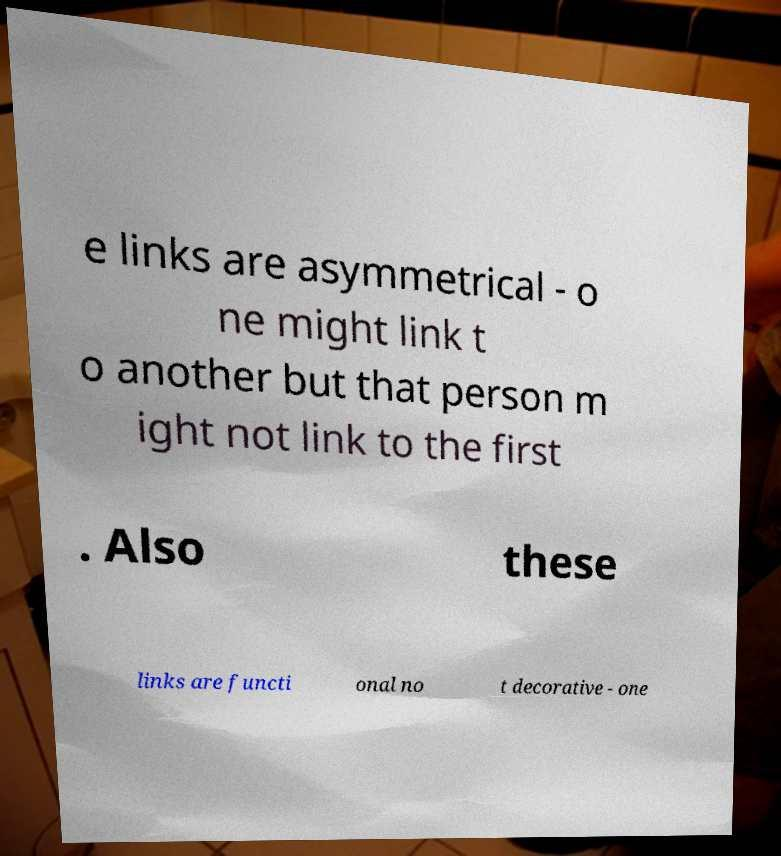Please identify and transcribe the text found in this image. e links are asymmetrical - o ne might link t o another but that person m ight not link to the first . Also these links are functi onal no t decorative - one 